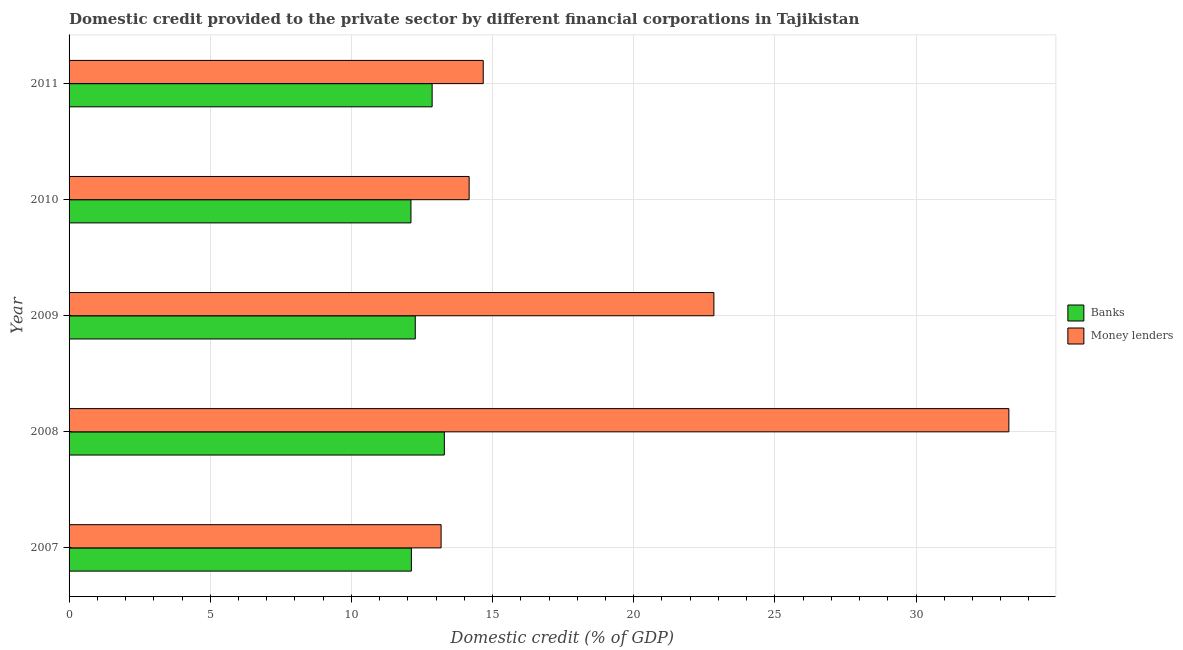How many different coloured bars are there?
Your response must be concise. 2. How many groups of bars are there?
Offer a very short reply. 5. Are the number of bars per tick equal to the number of legend labels?
Ensure brevity in your answer.  Yes. Are the number of bars on each tick of the Y-axis equal?
Offer a very short reply. Yes. How many bars are there on the 3rd tick from the bottom?
Keep it short and to the point. 2. What is the label of the 5th group of bars from the top?
Offer a terse response. 2007. In how many cases, is the number of bars for a given year not equal to the number of legend labels?
Provide a succinct answer. 0. What is the domestic credit provided by money lenders in 2011?
Give a very brief answer. 14.67. Across all years, what is the maximum domestic credit provided by banks?
Keep it short and to the point. 13.29. Across all years, what is the minimum domestic credit provided by money lenders?
Provide a succinct answer. 13.18. What is the total domestic credit provided by money lenders in the graph?
Offer a very short reply. 98.15. What is the difference between the domestic credit provided by banks in 2009 and that in 2010?
Provide a succinct answer. 0.15. What is the difference between the domestic credit provided by banks in 2011 and the domestic credit provided by money lenders in 2007?
Your answer should be very brief. -0.32. What is the average domestic credit provided by banks per year?
Your answer should be very brief. 12.53. In the year 2008, what is the difference between the domestic credit provided by banks and domestic credit provided by money lenders?
Offer a terse response. -20. What is the ratio of the domestic credit provided by banks in 2008 to that in 2009?
Provide a short and direct response. 1.08. Is the domestic credit provided by money lenders in 2008 less than that in 2011?
Your answer should be compact. No. What is the difference between the highest and the second highest domestic credit provided by banks?
Provide a succinct answer. 0.43. What is the difference between the highest and the lowest domestic credit provided by money lenders?
Provide a short and direct response. 20.11. In how many years, is the domestic credit provided by banks greater than the average domestic credit provided by banks taken over all years?
Provide a succinct answer. 2. What does the 1st bar from the top in 2008 represents?
Your response must be concise. Money lenders. What does the 2nd bar from the bottom in 2007 represents?
Provide a short and direct response. Money lenders. How many years are there in the graph?
Ensure brevity in your answer.  5. What is the difference between two consecutive major ticks on the X-axis?
Your answer should be very brief. 5. Are the values on the major ticks of X-axis written in scientific E-notation?
Your response must be concise. No. Does the graph contain any zero values?
Offer a terse response. No. What is the title of the graph?
Offer a very short reply. Domestic credit provided to the private sector by different financial corporations in Tajikistan. Does "Female entrants" appear as one of the legend labels in the graph?
Your answer should be very brief. No. What is the label or title of the X-axis?
Offer a terse response. Domestic credit (% of GDP). What is the Domestic credit (% of GDP) of Banks in 2007?
Offer a very short reply. 12.13. What is the Domestic credit (% of GDP) in Money lenders in 2007?
Provide a short and direct response. 13.18. What is the Domestic credit (% of GDP) in Banks in 2008?
Provide a short and direct response. 13.29. What is the Domestic credit (% of GDP) in Money lenders in 2008?
Ensure brevity in your answer.  33.29. What is the Domestic credit (% of GDP) in Banks in 2009?
Your response must be concise. 12.26. What is the Domestic credit (% of GDP) in Money lenders in 2009?
Ensure brevity in your answer.  22.84. What is the Domestic credit (% of GDP) in Banks in 2010?
Give a very brief answer. 12.11. What is the Domestic credit (% of GDP) of Money lenders in 2010?
Provide a succinct answer. 14.17. What is the Domestic credit (% of GDP) of Banks in 2011?
Keep it short and to the point. 12.86. What is the Domestic credit (% of GDP) in Money lenders in 2011?
Give a very brief answer. 14.67. Across all years, what is the maximum Domestic credit (% of GDP) in Banks?
Your answer should be very brief. 13.29. Across all years, what is the maximum Domestic credit (% of GDP) of Money lenders?
Keep it short and to the point. 33.29. Across all years, what is the minimum Domestic credit (% of GDP) in Banks?
Offer a very short reply. 12.11. Across all years, what is the minimum Domestic credit (% of GDP) in Money lenders?
Your response must be concise. 13.18. What is the total Domestic credit (% of GDP) of Banks in the graph?
Give a very brief answer. 62.65. What is the total Domestic credit (% of GDP) in Money lenders in the graph?
Offer a very short reply. 98.15. What is the difference between the Domestic credit (% of GDP) of Banks in 2007 and that in 2008?
Offer a very short reply. -1.17. What is the difference between the Domestic credit (% of GDP) of Money lenders in 2007 and that in 2008?
Provide a short and direct response. -20.11. What is the difference between the Domestic credit (% of GDP) in Banks in 2007 and that in 2009?
Provide a short and direct response. -0.14. What is the difference between the Domestic credit (% of GDP) of Money lenders in 2007 and that in 2009?
Your response must be concise. -9.66. What is the difference between the Domestic credit (% of GDP) of Banks in 2007 and that in 2010?
Provide a short and direct response. 0.02. What is the difference between the Domestic credit (% of GDP) in Money lenders in 2007 and that in 2010?
Your answer should be compact. -0.99. What is the difference between the Domestic credit (% of GDP) of Banks in 2007 and that in 2011?
Your answer should be compact. -0.73. What is the difference between the Domestic credit (% of GDP) of Money lenders in 2007 and that in 2011?
Ensure brevity in your answer.  -1.49. What is the difference between the Domestic credit (% of GDP) in Banks in 2008 and that in 2009?
Your answer should be compact. 1.03. What is the difference between the Domestic credit (% of GDP) of Money lenders in 2008 and that in 2009?
Keep it short and to the point. 10.45. What is the difference between the Domestic credit (% of GDP) of Banks in 2008 and that in 2010?
Provide a succinct answer. 1.18. What is the difference between the Domestic credit (% of GDP) in Money lenders in 2008 and that in 2010?
Your answer should be compact. 19.12. What is the difference between the Domestic credit (% of GDP) in Banks in 2008 and that in 2011?
Your answer should be compact. 0.43. What is the difference between the Domestic credit (% of GDP) of Money lenders in 2008 and that in 2011?
Provide a succinct answer. 18.62. What is the difference between the Domestic credit (% of GDP) of Banks in 2009 and that in 2010?
Keep it short and to the point. 0.15. What is the difference between the Domestic credit (% of GDP) of Money lenders in 2009 and that in 2010?
Your answer should be compact. 8.67. What is the difference between the Domestic credit (% of GDP) of Banks in 2009 and that in 2011?
Your response must be concise. -0.6. What is the difference between the Domestic credit (% of GDP) of Money lenders in 2009 and that in 2011?
Ensure brevity in your answer.  8.17. What is the difference between the Domestic credit (% of GDP) in Banks in 2010 and that in 2011?
Ensure brevity in your answer.  -0.75. What is the difference between the Domestic credit (% of GDP) of Money lenders in 2010 and that in 2011?
Make the answer very short. -0.5. What is the difference between the Domestic credit (% of GDP) in Banks in 2007 and the Domestic credit (% of GDP) in Money lenders in 2008?
Offer a terse response. -21.16. What is the difference between the Domestic credit (% of GDP) of Banks in 2007 and the Domestic credit (% of GDP) of Money lenders in 2009?
Provide a succinct answer. -10.71. What is the difference between the Domestic credit (% of GDP) of Banks in 2007 and the Domestic credit (% of GDP) of Money lenders in 2010?
Provide a succinct answer. -2.05. What is the difference between the Domestic credit (% of GDP) in Banks in 2007 and the Domestic credit (% of GDP) in Money lenders in 2011?
Your response must be concise. -2.54. What is the difference between the Domestic credit (% of GDP) in Banks in 2008 and the Domestic credit (% of GDP) in Money lenders in 2009?
Provide a short and direct response. -9.55. What is the difference between the Domestic credit (% of GDP) in Banks in 2008 and the Domestic credit (% of GDP) in Money lenders in 2010?
Offer a terse response. -0.88. What is the difference between the Domestic credit (% of GDP) in Banks in 2008 and the Domestic credit (% of GDP) in Money lenders in 2011?
Your answer should be compact. -1.38. What is the difference between the Domestic credit (% of GDP) in Banks in 2009 and the Domestic credit (% of GDP) in Money lenders in 2010?
Your answer should be compact. -1.91. What is the difference between the Domestic credit (% of GDP) of Banks in 2009 and the Domestic credit (% of GDP) of Money lenders in 2011?
Provide a succinct answer. -2.41. What is the difference between the Domestic credit (% of GDP) of Banks in 2010 and the Domestic credit (% of GDP) of Money lenders in 2011?
Your response must be concise. -2.56. What is the average Domestic credit (% of GDP) of Banks per year?
Keep it short and to the point. 12.53. What is the average Domestic credit (% of GDP) of Money lenders per year?
Offer a very short reply. 19.63. In the year 2007, what is the difference between the Domestic credit (% of GDP) of Banks and Domestic credit (% of GDP) of Money lenders?
Your response must be concise. -1.05. In the year 2008, what is the difference between the Domestic credit (% of GDP) of Banks and Domestic credit (% of GDP) of Money lenders?
Provide a succinct answer. -20. In the year 2009, what is the difference between the Domestic credit (% of GDP) of Banks and Domestic credit (% of GDP) of Money lenders?
Provide a succinct answer. -10.58. In the year 2010, what is the difference between the Domestic credit (% of GDP) of Banks and Domestic credit (% of GDP) of Money lenders?
Give a very brief answer. -2.06. In the year 2011, what is the difference between the Domestic credit (% of GDP) of Banks and Domestic credit (% of GDP) of Money lenders?
Your response must be concise. -1.81. What is the ratio of the Domestic credit (% of GDP) of Banks in 2007 to that in 2008?
Keep it short and to the point. 0.91. What is the ratio of the Domestic credit (% of GDP) in Money lenders in 2007 to that in 2008?
Provide a succinct answer. 0.4. What is the ratio of the Domestic credit (% of GDP) of Banks in 2007 to that in 2009?
Offer a terse response. 0.99. What is the ratio of the Domestic credit (% of GDP) of Money lenders in 2007 to that in 2009?
Give a very brief answer. 0.58. What is the ratio of the Domestic credit (% of GDP) in Banks in 2007 to that in 2010?
Offer a very short reply. 1. What is the ratio of the Domestic credit (% of GDP) of Money lenders in 2007 to that in 2010?
Your response must be concise. 0.93. What is the ratio of the Domestic credit (% of GDP) in Banks in 2007 to that in 2011?
Your answer should be very brief. 0.94. What is the ratio of the Domestic credit (% of GDP) in Money lenders in 2007 to that in 2011?
Make the answer very short. 0.9. What is the ratio of the Domestic credit (% of GDP) of Banks in 2008 to that in 2009?
Provide a succinct answer. 1.08. What is the ratio of the Domestic credit (% of GDP) in Money lenders in 2008 to that in 2009?
Provide a short and direct response. 1.46. What is the ratio of the Domestic credit (% of GDP) of Banks in 2008 to that in 2010?
Your answer should be very brief. 1.1. What is the ratio of the Domestic credit (% of GDP) of Money lenders in 2008 to that in 2010?
Make the answer very short. 2.35. What is the ratio of the Domestic credit (% of GDP) of Banks in 2008 to that in 2011?
Your response must be concise. 1.03. What is the ratio of the Domestic credit (% of GDP) in Money lenders in 2008 to that in 2011?
Provide a short and direct response. 2.27. What is the ratio of the Domestic credit (% of GDP) of Banks in 2009 to that in 2010?
Your answer should be compact. 1.01. What is the ratio of the Domestic credit (% of GDP) of Money lenders in 2009 to that in 2010?
Your response must be concise. 1.61. What is the ratio of the Domestic credit (% of GDP) in Banks in 2009 to that in 2011?
Give a very brief answer. 0.95. What is the ratio of the Domestic credit (% of GDP) in Money lenders in 2009 to that in 2011?
Your answer should be compact. 1.56. What is the ratio of the Domestic credit (% of GDP) in Banks in 2010 to that in 2011?
Offer a very short reply. 0.94. What is the ratio of the Domestic credit (% of GDP) of Money lenders in 2010 to that in 2011?
Keep it short and to the point. 0.97. What is the difference between the highest and the second highest Domestic credit (% of GDP) of Banks?
Your answer should be very brief. 0.43. What is the difference between the highest and the second highest Domestic credit (% of GDP) in Money lenders?
Make the answer very short. 10.45. What is the difference between the highest and the lowest Domestic credit (% of GDP) in Banks?
Offer a terse response. 1.18. What is the difference between the highest and the lowest Domestic credit (% of GDP) in Money lenders?
Your answer should be very brief. 20.11. 